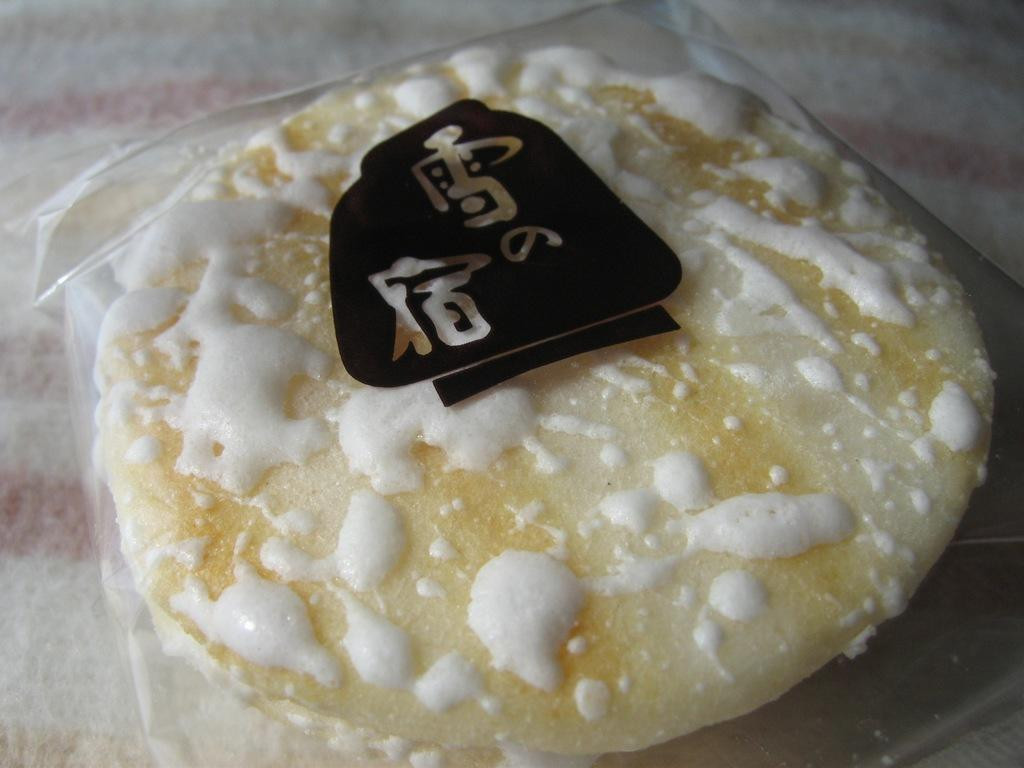What is the main subject of the image? The main subject of the image is food on a table. Can you describe the food in more detail? Unfortunately, the provided facts do not give any specific details about the food. Are there any utensils or plates visible in the image? The provided facts do not mention any utensils or plates. What type of rhythm can be heard coming from the wall in the image? There is no wall or any sound mentioned in the image, so it's not possible to determine what rhythm might be heard. 